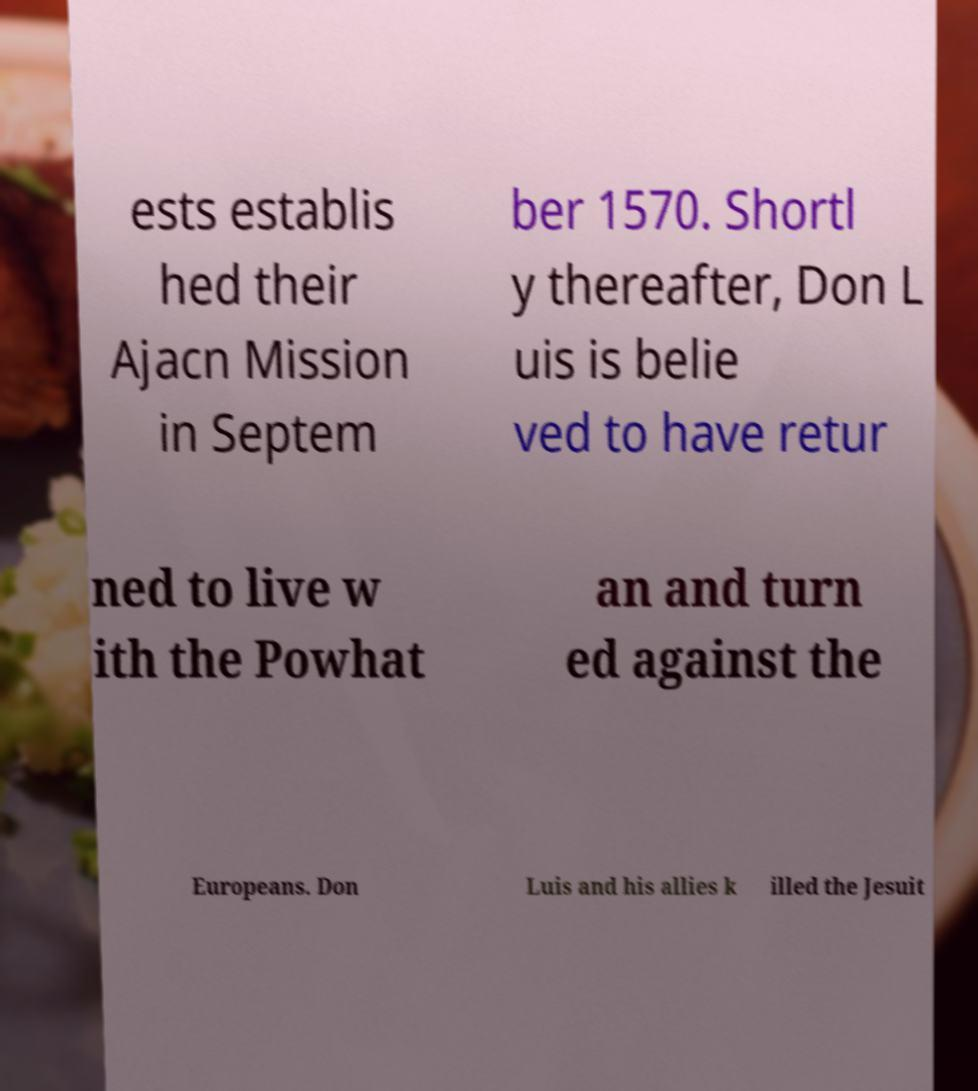Can you accurately transcribe the text from the provided image for me? ests establis hed their Ajacn Mission in Septem ber 1570. Shortl y thereafter, Don L uis is belie ved to have retur ned to live w ith the Powhat an and turn ed against the Europeans. Don Luis and his allies k illed the Jesuit 